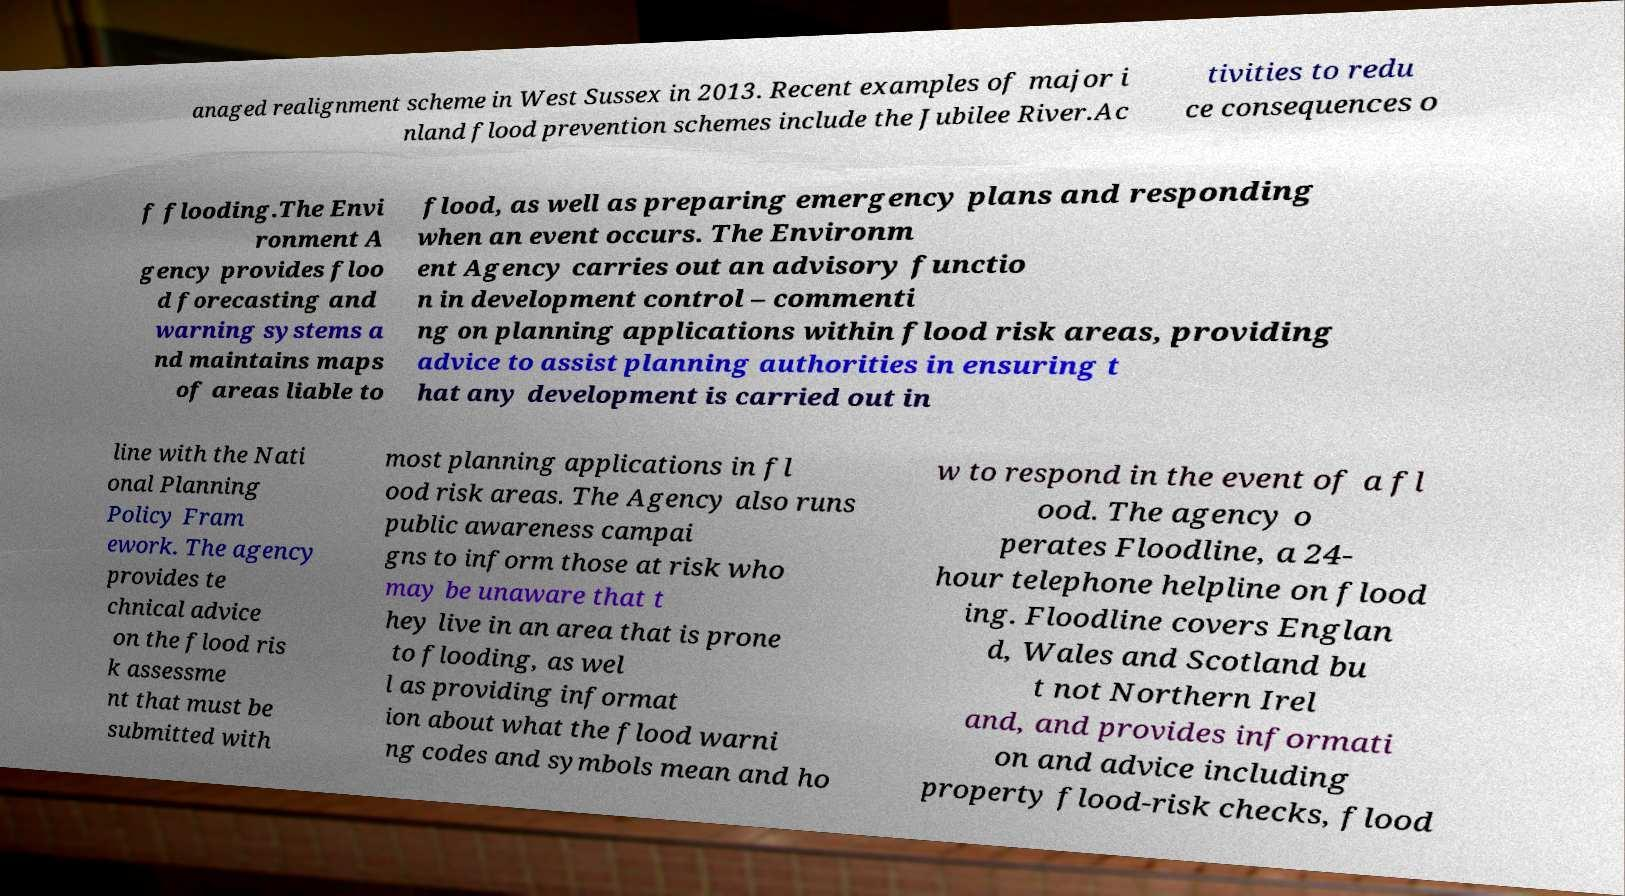There's text embedded in this image that I need extracted. Can you transcribe it verbatim? anaged realignment scheme in West Sussex in 2013. Recent examples of major i nland flood prevention schemes include the Jubilee River.Ac tivities to redu ce consequences o f flooding.The Envi ronment A gency provides floo d forecasting and warning systems a nd maintains maps of areas liable to flood, as well as preparing emergency plans and responding when an event occurs. The Environm ent Agency carries out an advisory functio n in development control – commenti ng on planning applications within flood risk areas, providing advice to assist planning authorities in ensuring t hat any development is carried out in line with the Nati onal Planning Policy Fram ework. The agency provides te chnical advice on the flood ris k assessme nt that must be submitted with most planning applications in fl ood risk areas. The Agency also runs public awareness campai gns to inform those at risk who may be unaware that t hey live in an area that is prone to flooding, as wel l as providing informat ion about what the flood warni ng codes and symbols mean and ho w to respond in the event of a fl ood. The agency o perates Floodline, a 24- hour telephone helpline on flood ing. Floodline covers Englan d, Wales and Scotland bu t not Northern Irel and, and provides informati on and advice including property flood-risk checks, flood 